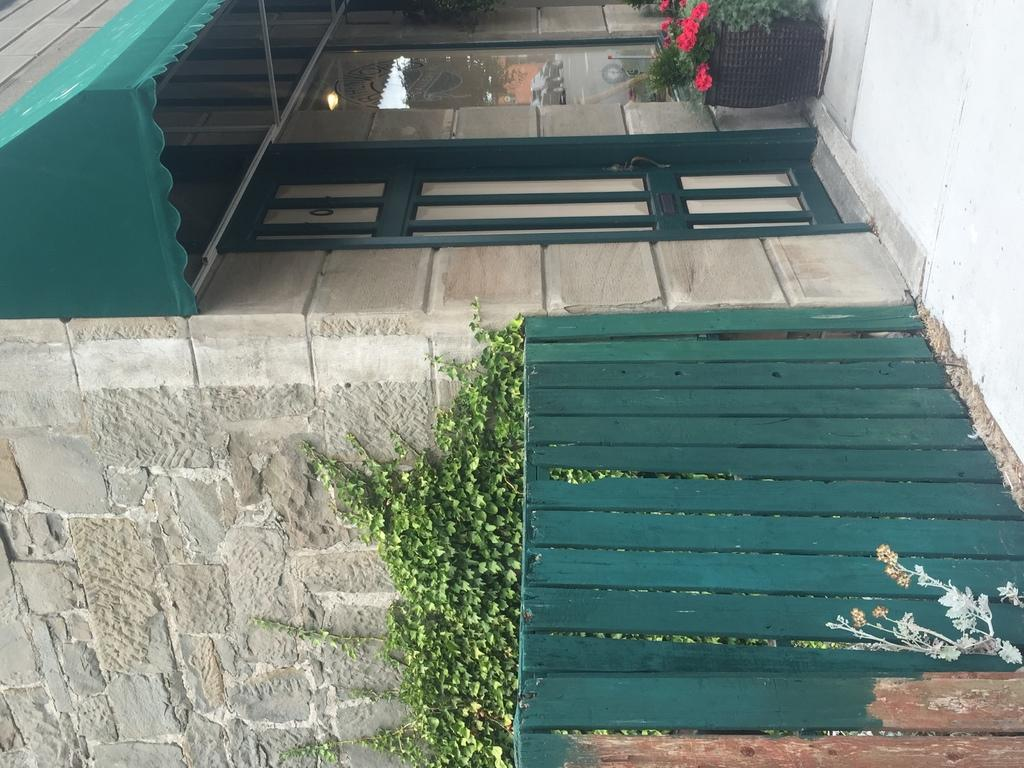What type of structure is present in the image? There is a building in the image. What is separating the building from the surrounding area? There is a fence in the image. What type of vegetation can be seen in the image? There are plants in the image. What are the plants contained in? There are flower pots in the image. What surface can be seen beneath the building and fence? The ground is visible in the image. What time of day is it in the image? The provided facts do not mention the time of day, so it cannot be determined from the image. How many times has the building been kicked in the image? There is no indication of any kicking in the image. 